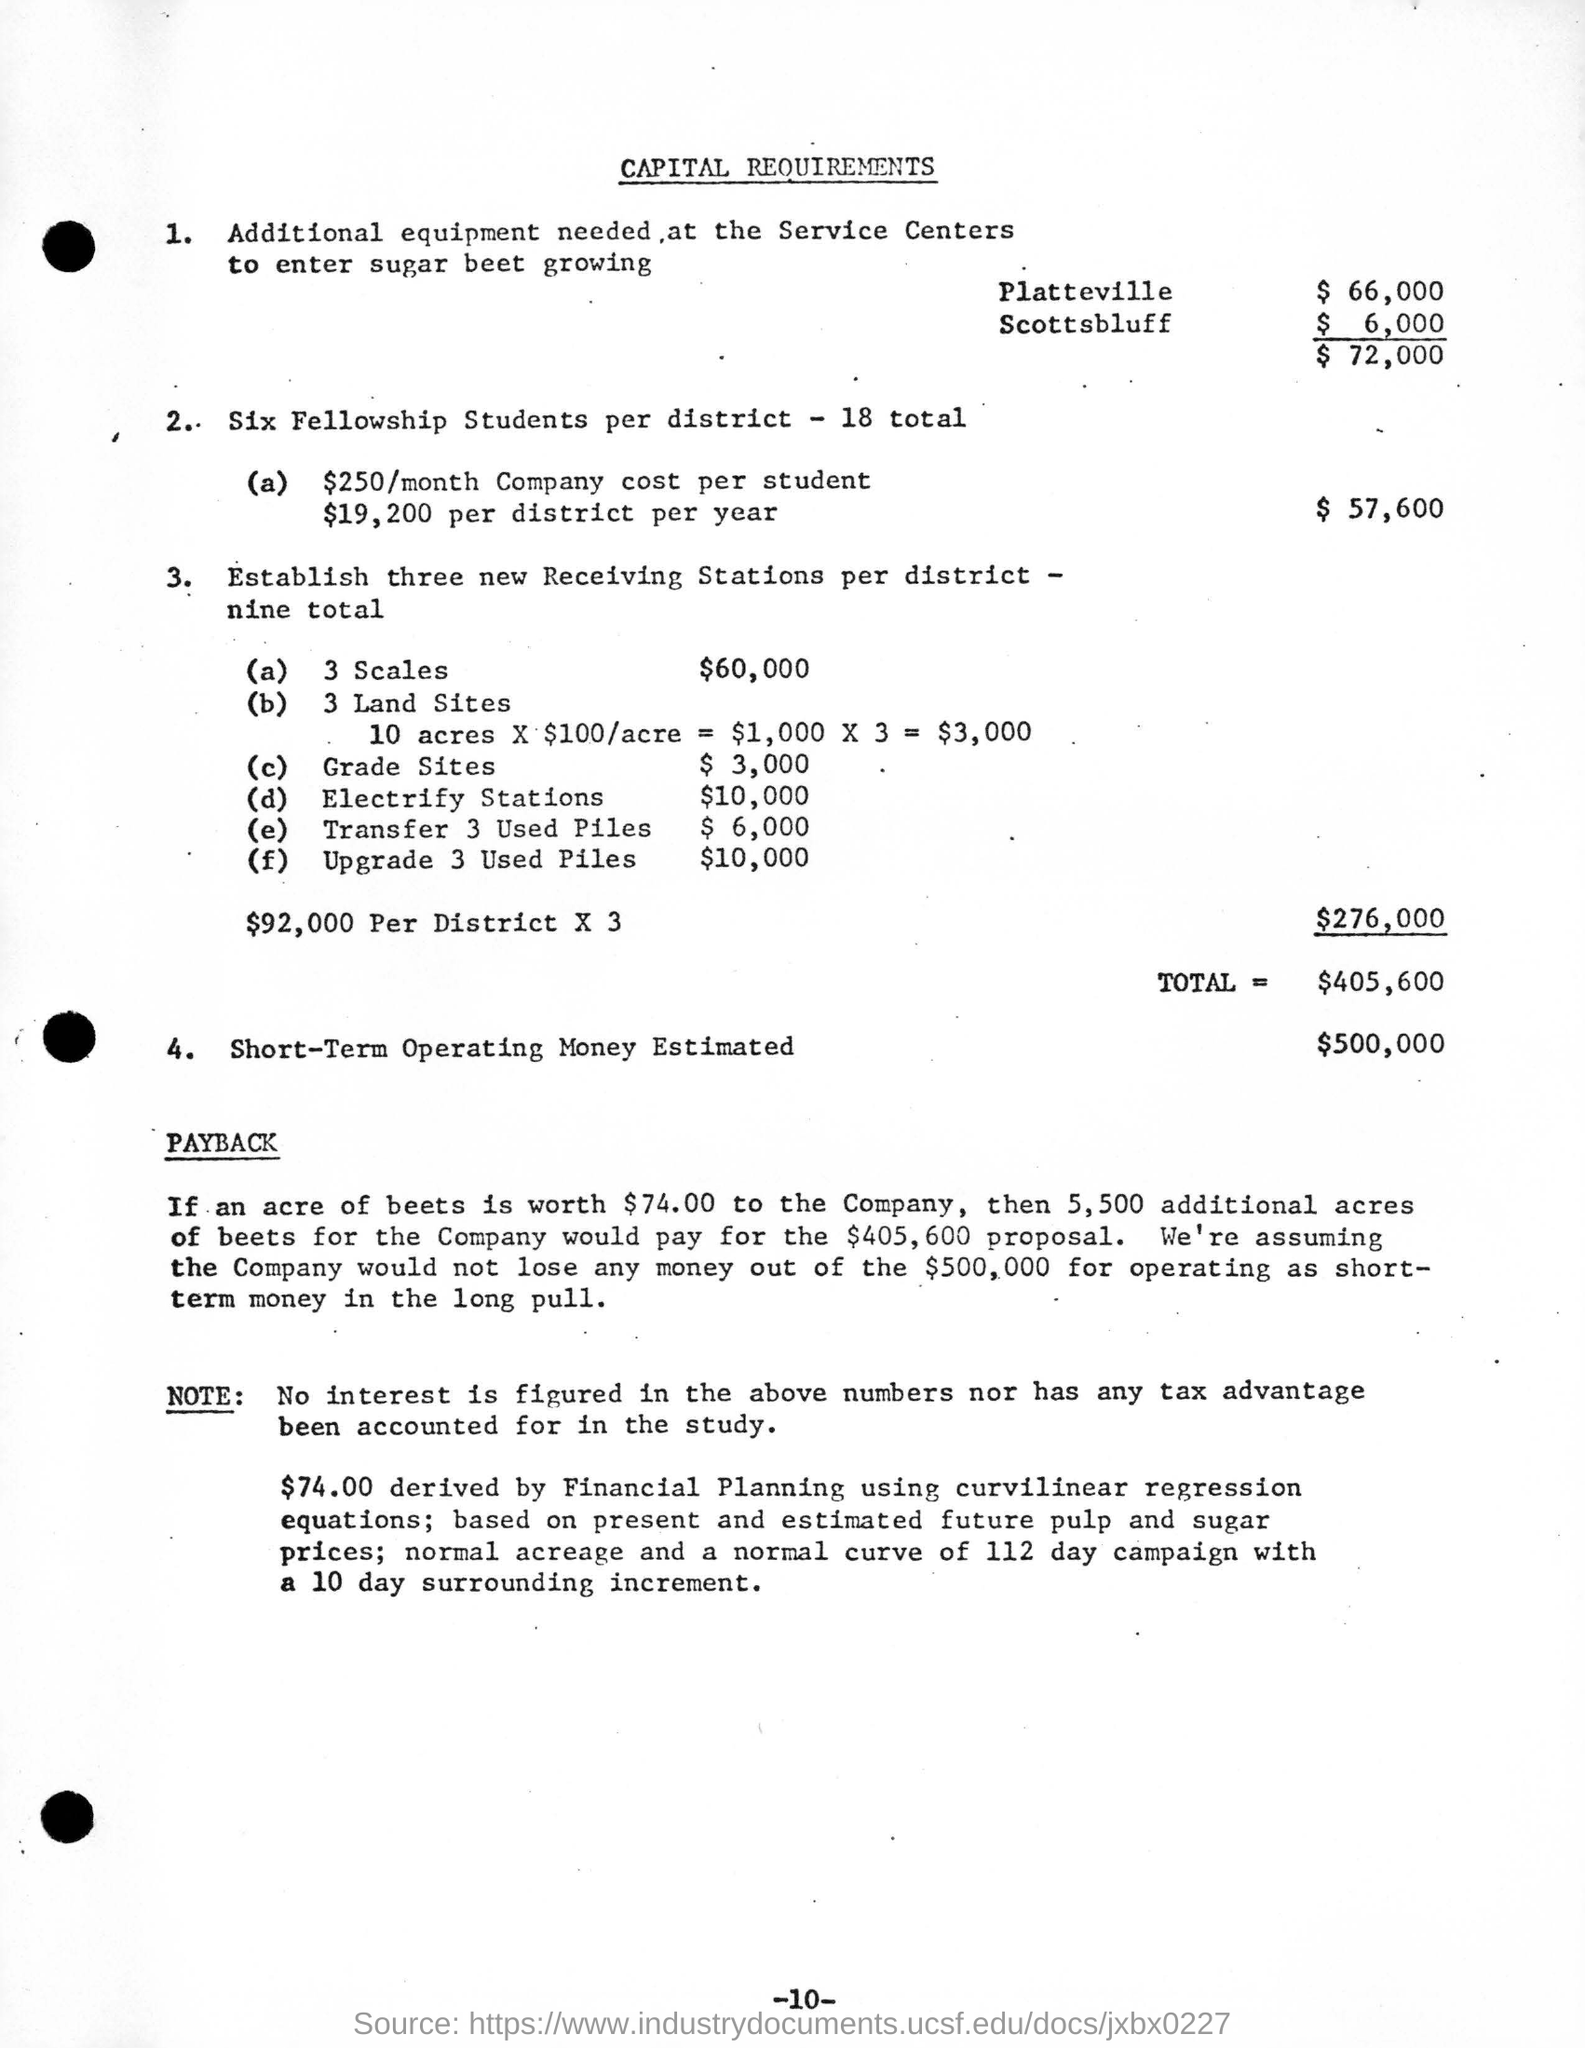What is monthly company cost per student?
Offer a terse response. $250. How much is the short term operating money estimated?
Keep it short and to the point. $500,000. How many fellowship students per district?
Keep it short and to the point. Six. What is the amount derived by Financial planning?
Your answer should be compact. $74.00. What is the total cost of buying additional equipment needed at the service centres to enter sugar beet growing?
Provide a short and direct response. $72,000. 